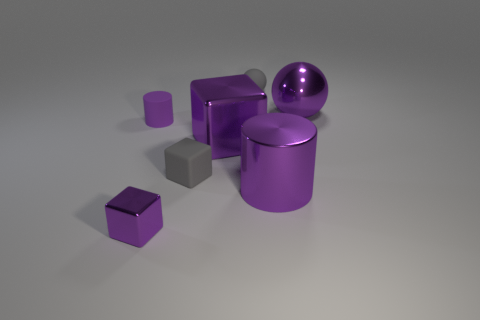How many rubber objects have the same color as the tiny rubber cube?
Your answer should be very brief. 1. There is a shiny object that is both on the right side of the small rubber ball and left of the big purple ball; what is its size?
Your answer should be compact. Large. What number of matte objects are either small gray blocks or large gray things?
Provide a succinct answer. 1. What is the gray ball made of?
Offer a terse response. Rubber. There is a big object in front of the shiny cube to the right of the gray matte thing that is in front of the purple metal ball; what is it made of?
Make the answer very short. Metal. The gray rubber thing that is the same size as the gray rubber block is what shape?
Offer a terse response. Sphere. What number of objects are either purple balls or purple objects behind the small metal cube?
Give a very brief answer. 4. Are the big thing that is left of the small rubber ball and the cylinder that is on the right side of the tiny matte cube made of the same material?
Ensure brevity in your answer.  Yes. There is a small metal object that is the same color as the large shiny sphere; what is its shape?
Make the answer very short. Cube. What number of brown objects are either shiny cylinders or tiny cylinders?
Your answer should be very brief. 0. 